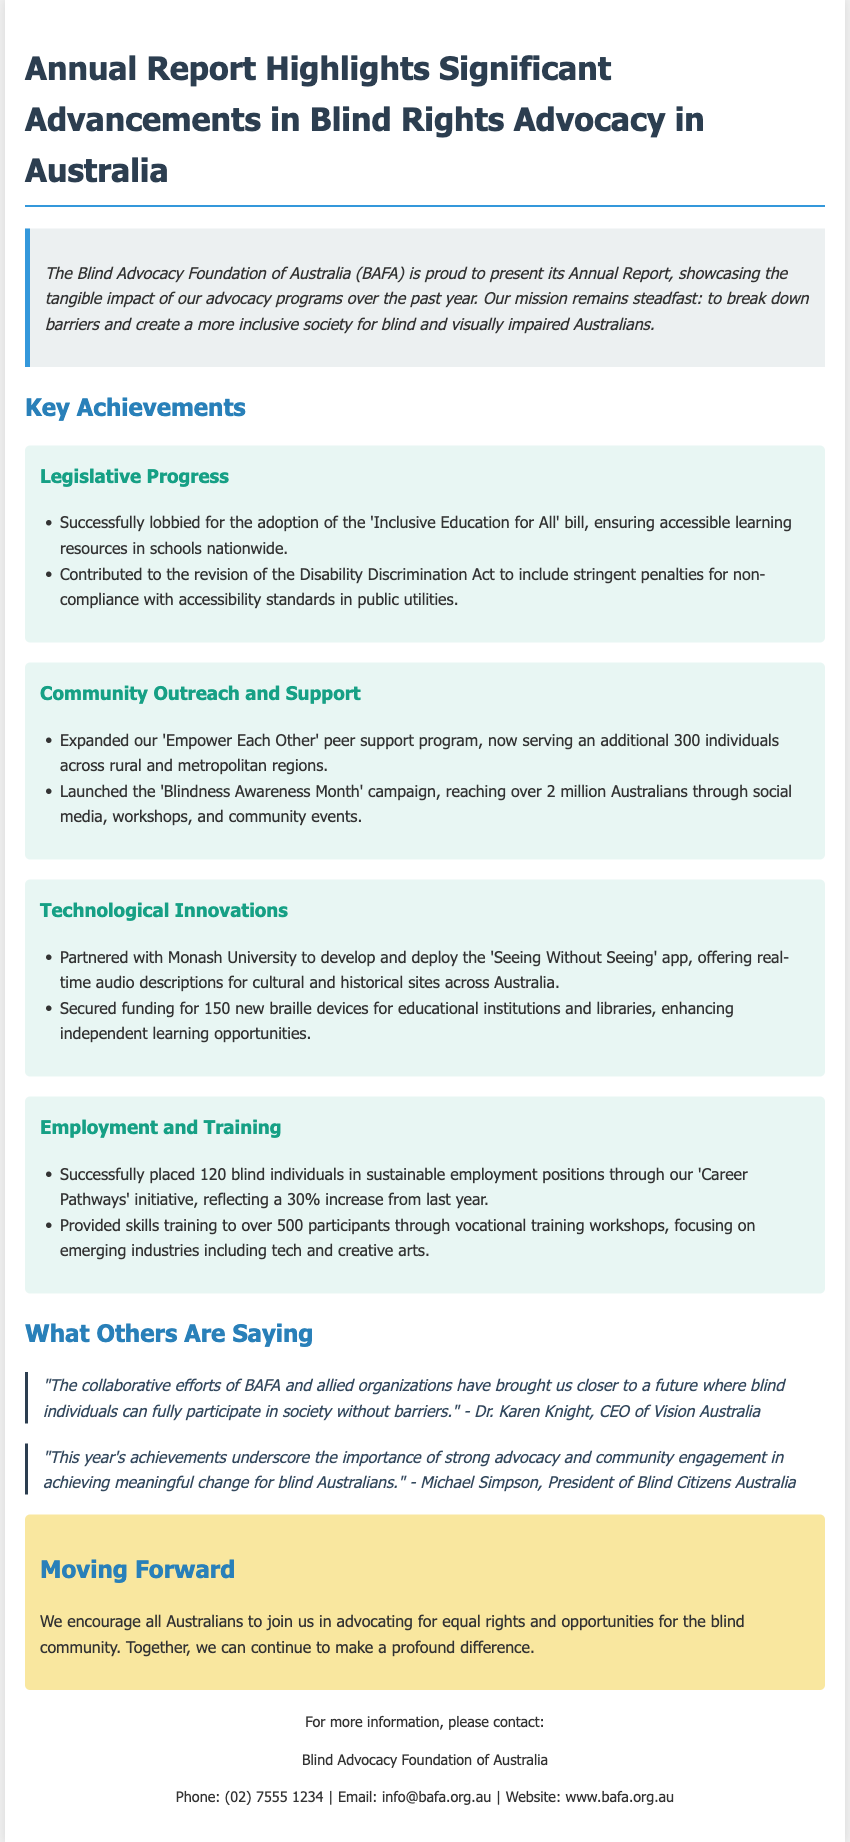what is the name of the foundation? The foundation mentioned in the document is the Blind Advocacy Foundation of Australia.
Answer: Blind Advocacy Foundation of Australia how many individuals does the 'Empower Each Other' program serve? The 'Empower Each Other' peer support program now serves an additional 300 individuals.
Answer: 300 individuals what legislative bill was adopted? The advocacy successfully lobbied for the adoption of the 'Inclusive Education for All' bill.
Answer: Inclusive Education for All how many blind individuals were placed in employment this year? A total of 120 blind individuals were placed in sustainable employment positions.
Answer: 120 who is the CEO of Vision Australia? The CEO of Vision Australia is Dr. Karen Knight.
Answer: Dr. Karen Knight what percentage increase in placements occurred this year? The document states a 30% increase in the placement of blind individuals in sustainable employment positions compared to last year.
Answer: 30% what is the main focus of the vocational training workshops? The main focus of the vocational training workshops is on emerging industries including tech and creative arts.
Answer: tech and creative arts which campaign reached over 2 million Australians? The campaign that reached over 2 million Australians is the 'Blindness Awareness Month' campaign.
Answer: Blindness Awareness Month how many braille devices were secured for educational institutions? 150 new braille devices were secured for educational institutions and libraries.
Answer: 150 